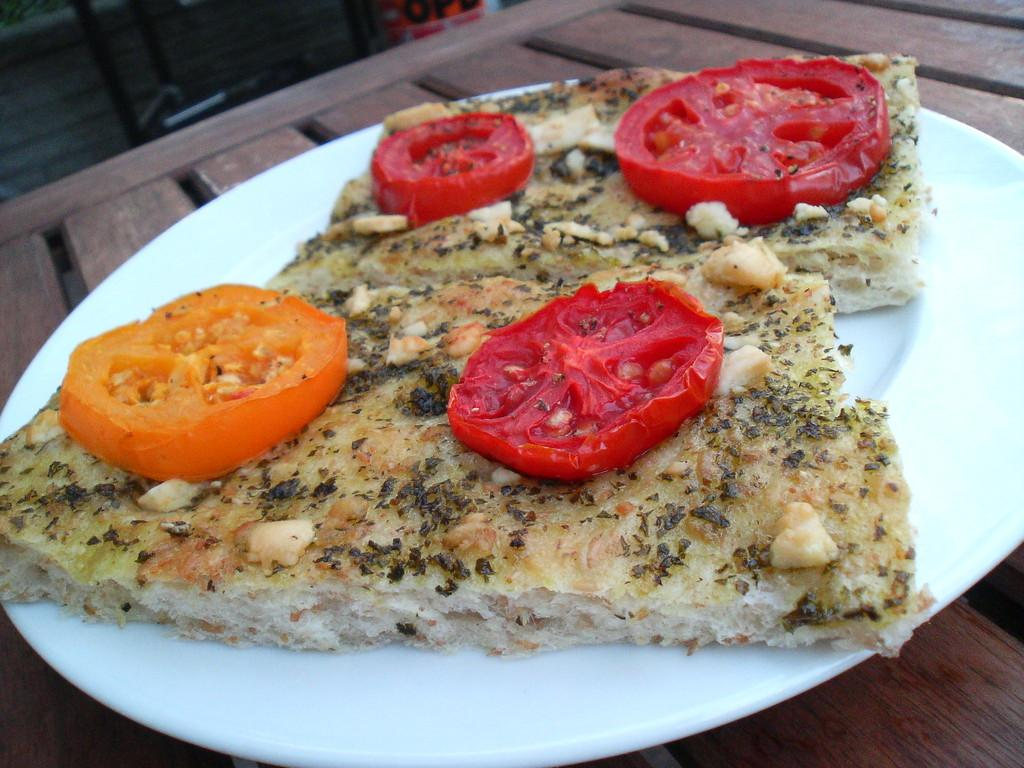What type of surface is visible in the image? There is a wooden platform in the image. What is placed on the wooden platform? There is food on the wooden platform. Can you describe a specific type of food that can be seen on the wooden platform? There are tomato slices on a white plate in the image. What type of light is shining on the tomato slices in the image? There is no specific light source mentioned in the image, so it cannot be determined what type of light is shining on the tomato slices. 